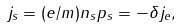Convert formula to latex. <formula><loc_0><loc_0><loc_500><loc_500>j _ { s } = ( e / m ) n _ { s } p _ { s } = - \delta j _ { e } ,</formula> 